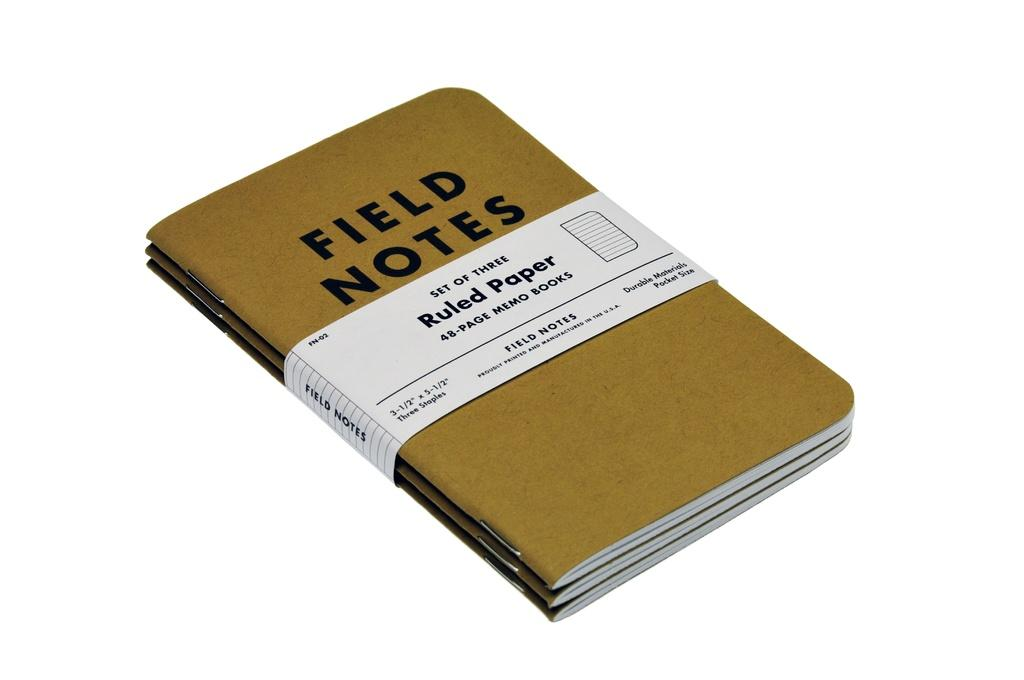<image>
Provide a brief description of the given image. A set of three ruled paper and field notes. 